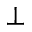<formula> <loc_0><loc_0><loc_500><loc_500>\bot</formula> 